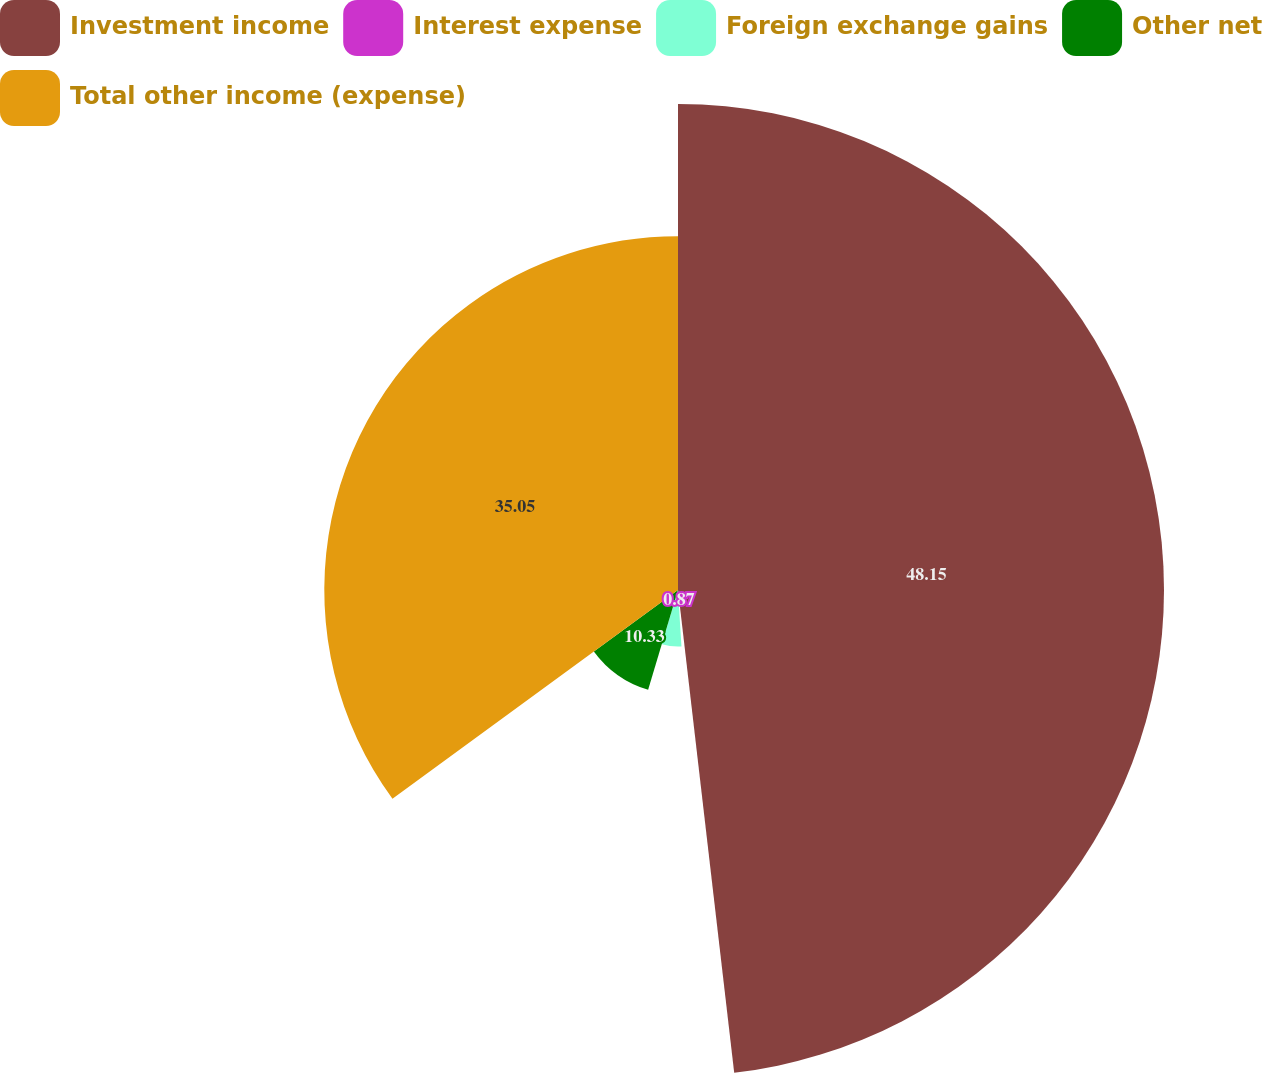Convert chart. <chart><loc_0><loc_0><loc_500><loc_500><pie_chart><fcel>Investment income<fcel>Interest expense<fcel>Foreign exchange gains<fcel>Other net<fcel>Total other income (expense)<nl><fcel>48.16%<fcel>0.87%<fcel>5.6%<fcel>10.33%<fcel>35.05%<nl></chart> 